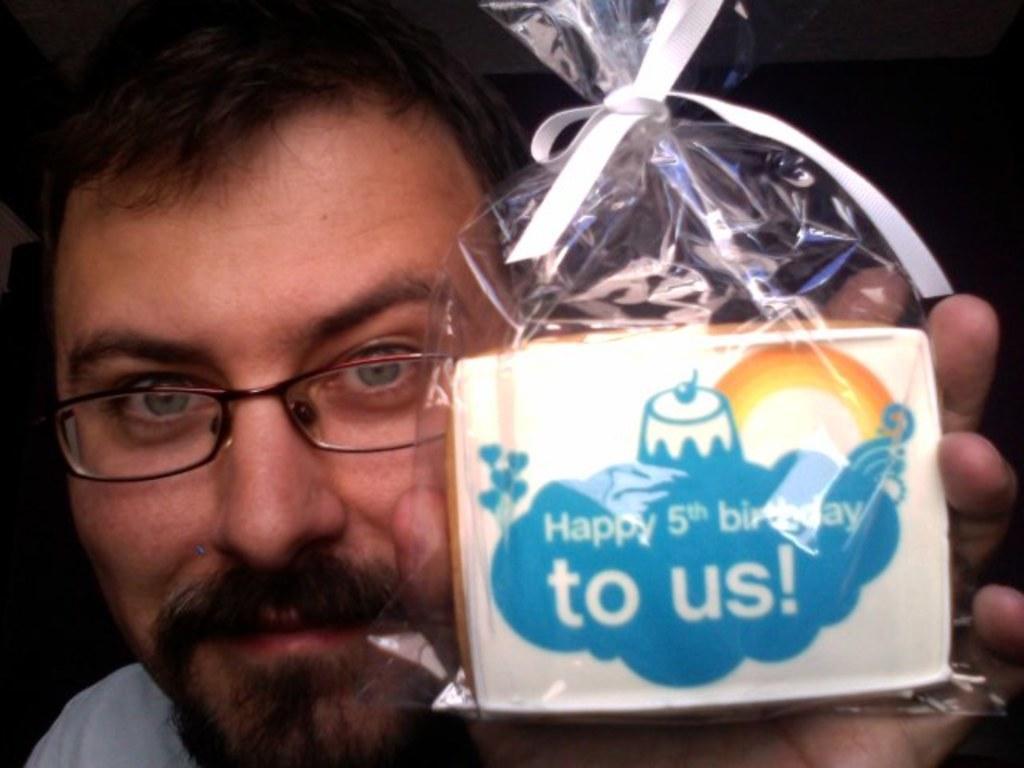How would you summarize this image in a sentence or two? In this picture we can see a man, he is holding a gift in his hand, he wore spectacles, we can see a white color ribbon here. 